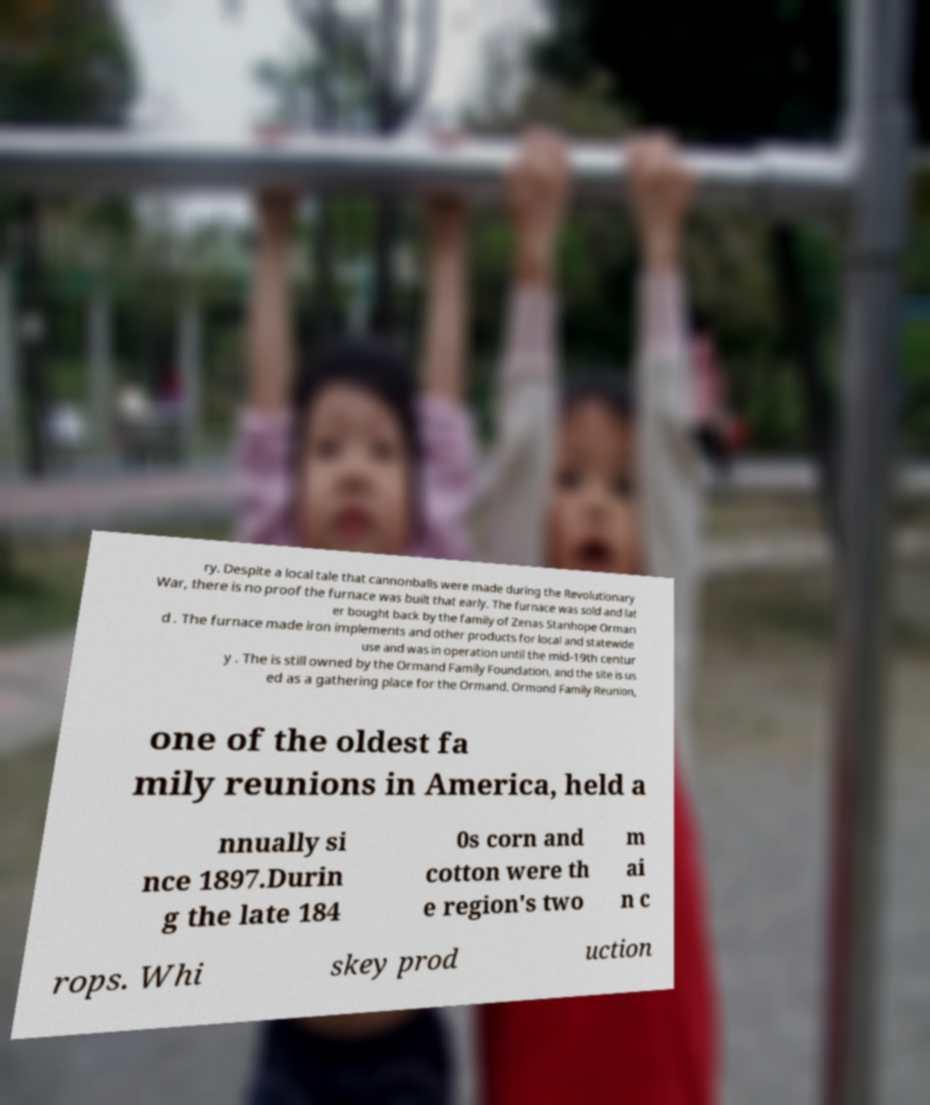For documentation purposes, I need the text within this image transcribed. Could you provide that? ry. Despite a local tale that cannonballs were made during the Revolutionary War, there is no proof the furnace was built that early. The furnace was sold and lat er bought back by the family of Zenas Stanhope Orman d . The furnace made iron implements and other products for local and statewide use and was in operation until the mid-19th centur y . The is still owned by the Ormand Family Foundation, and the site is us ed as a gathering place for the Ormand, Ormond Family Reunion, one of the oldest fa mily reunions in America, held a nnually si nce 1897.Durin g the late 184 0s corn and cotton were th e region's two m ai n c rops. Whi skey prod uction 